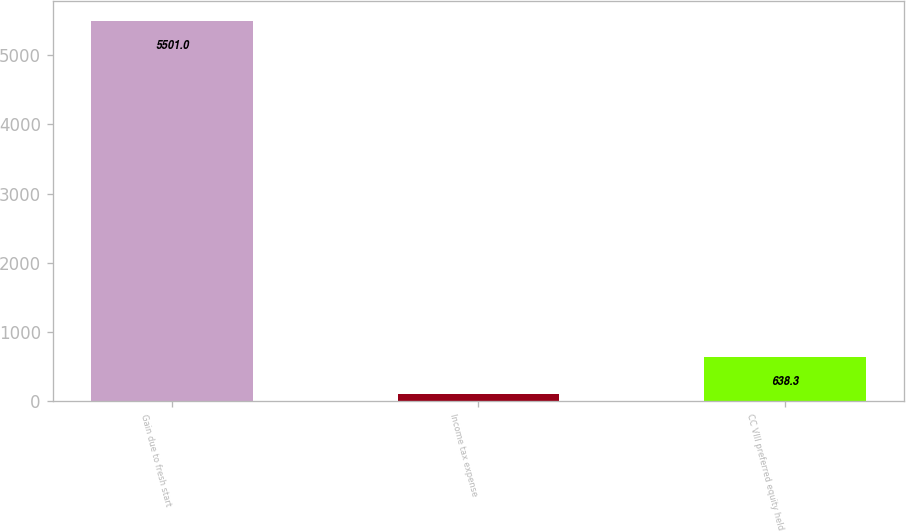<chart> <loc_0><loc_0><loc_500><loc_500><bar_chart><fcel>Gain due to fresh start<fcel>Income tax expense<fcel>CC VIII preferred equity held<nl><fcel>5501<fcel>98<fcel>638.3<nl></chart> 